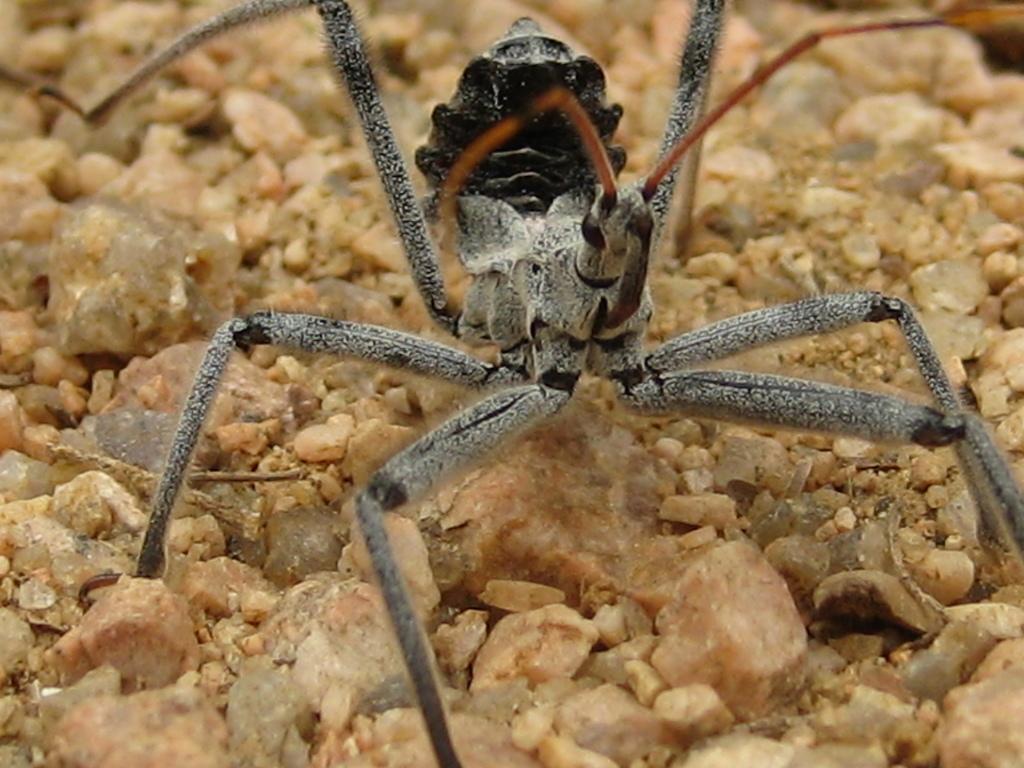Describe this image in one or two sentences. In this picture, we see an insect in grey, black and red color. It has six legs. At the bottom, we see the stones. 